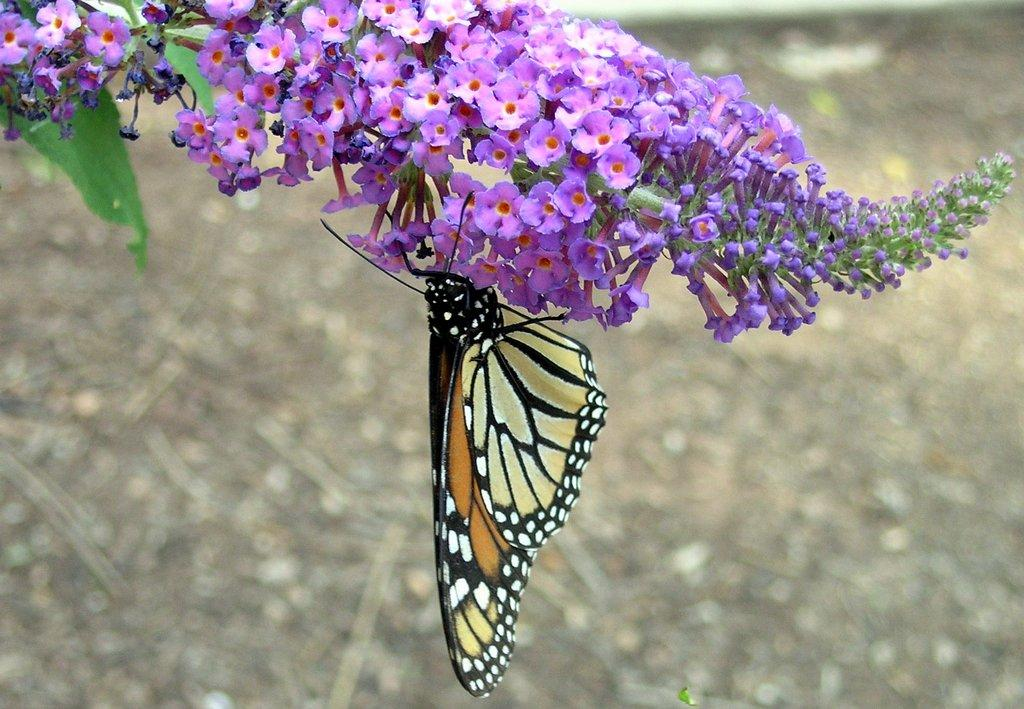What type of plants can be seen in the image? There are flowers in the image. What insect is present in the image? There is a butterfly in the image. What part of the plant is visible in the image? There is a leaf in the image. What is visible at the bottom of the image? The ground is visible at the bottom of the image. Where is the hen located in the image? There is no hen present in the image. What type of stem can be seen supporting the flowers in the image? There is no stem visible in the image; only a leaf is present. 